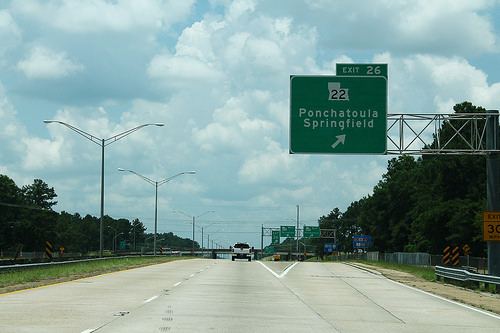<image>
Is the car under the sky? Yes. The car is positioned underneath the sky, with the sky above it in the vertical space. 